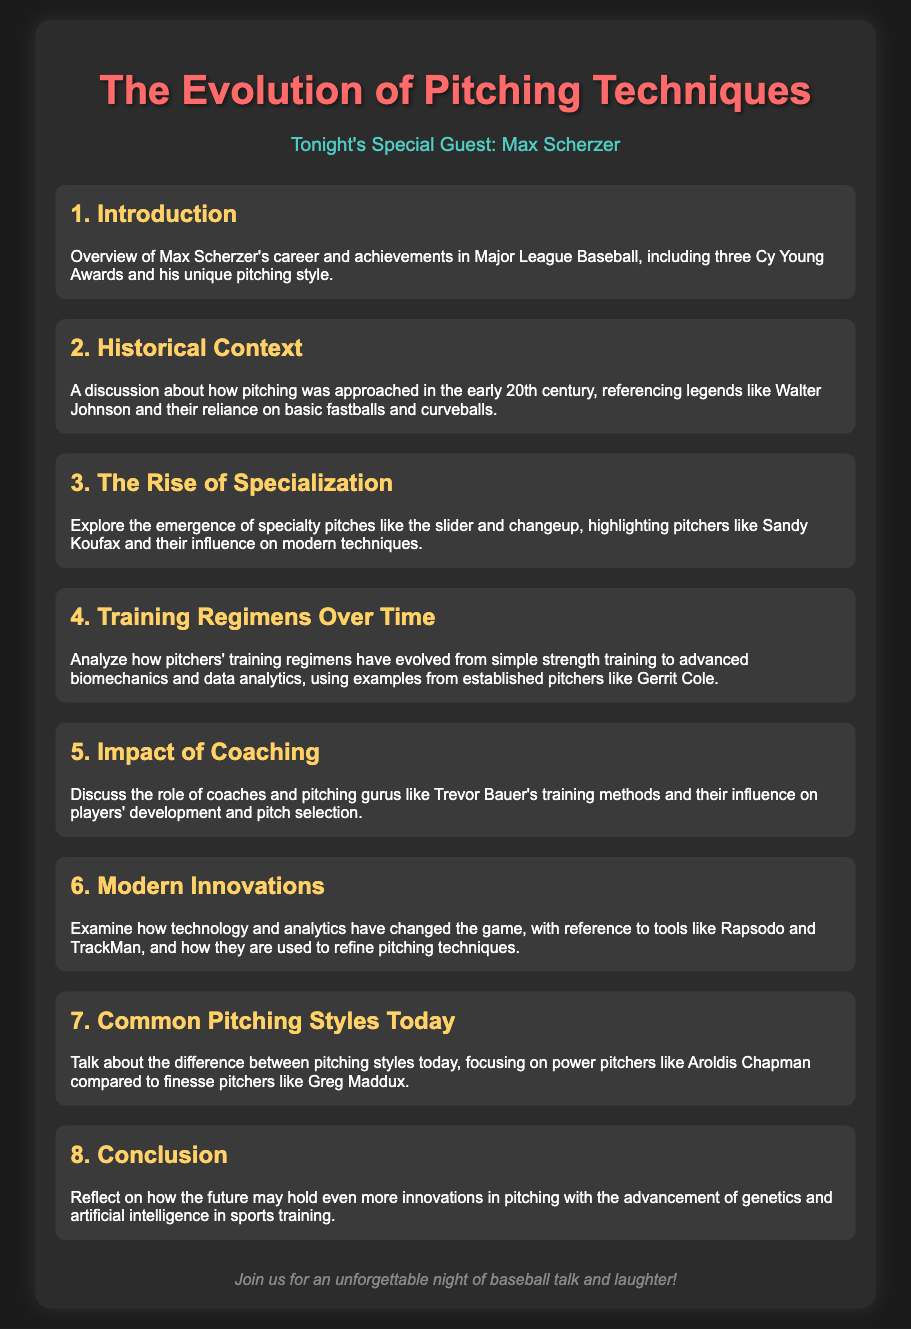What awards has Max Scherzer won? The document mentions that Max Scherzer has won three Cy Young Awards.
Answer: three Cy Young Awards Who is featured as the special guest? The guest highlighted in the document is Max Scherzer.
Answer: Max Scherzer Which century is referenced for early pitching techniques? The document discusses early pitching in the early 20th century.
Answer: early 20th century What specialty pitch is mentioned in relation to Sandy Koufax? The document highlights the slider as a specialty pitch associated with Sandy Koufax.
Answer: slider What modern tools are discussed for refining pitching techniques? The document mentions Rapsodo and TrackMan as tools used for refining techniques.
Answer: Rapsodo and TrackMan What type of training regimens have evolved according to the document? The document discusses the evolution of training regimens from simple strength training to advanced biomechanics.
Answer: advanced biomechanics Who are the finesse and power pitchers discussed? The document compares Aroldis Chapman as a power pitcher and Greg Maddux as a finesse pitcher.
Answer: Aroldis Chapman and Greg Maddux What future advancements in pitching are suggested? The document suggests that advancements in genetics and artificial intelligence may influence the future of pitching.
Answer: genetics and artificial intelligence 